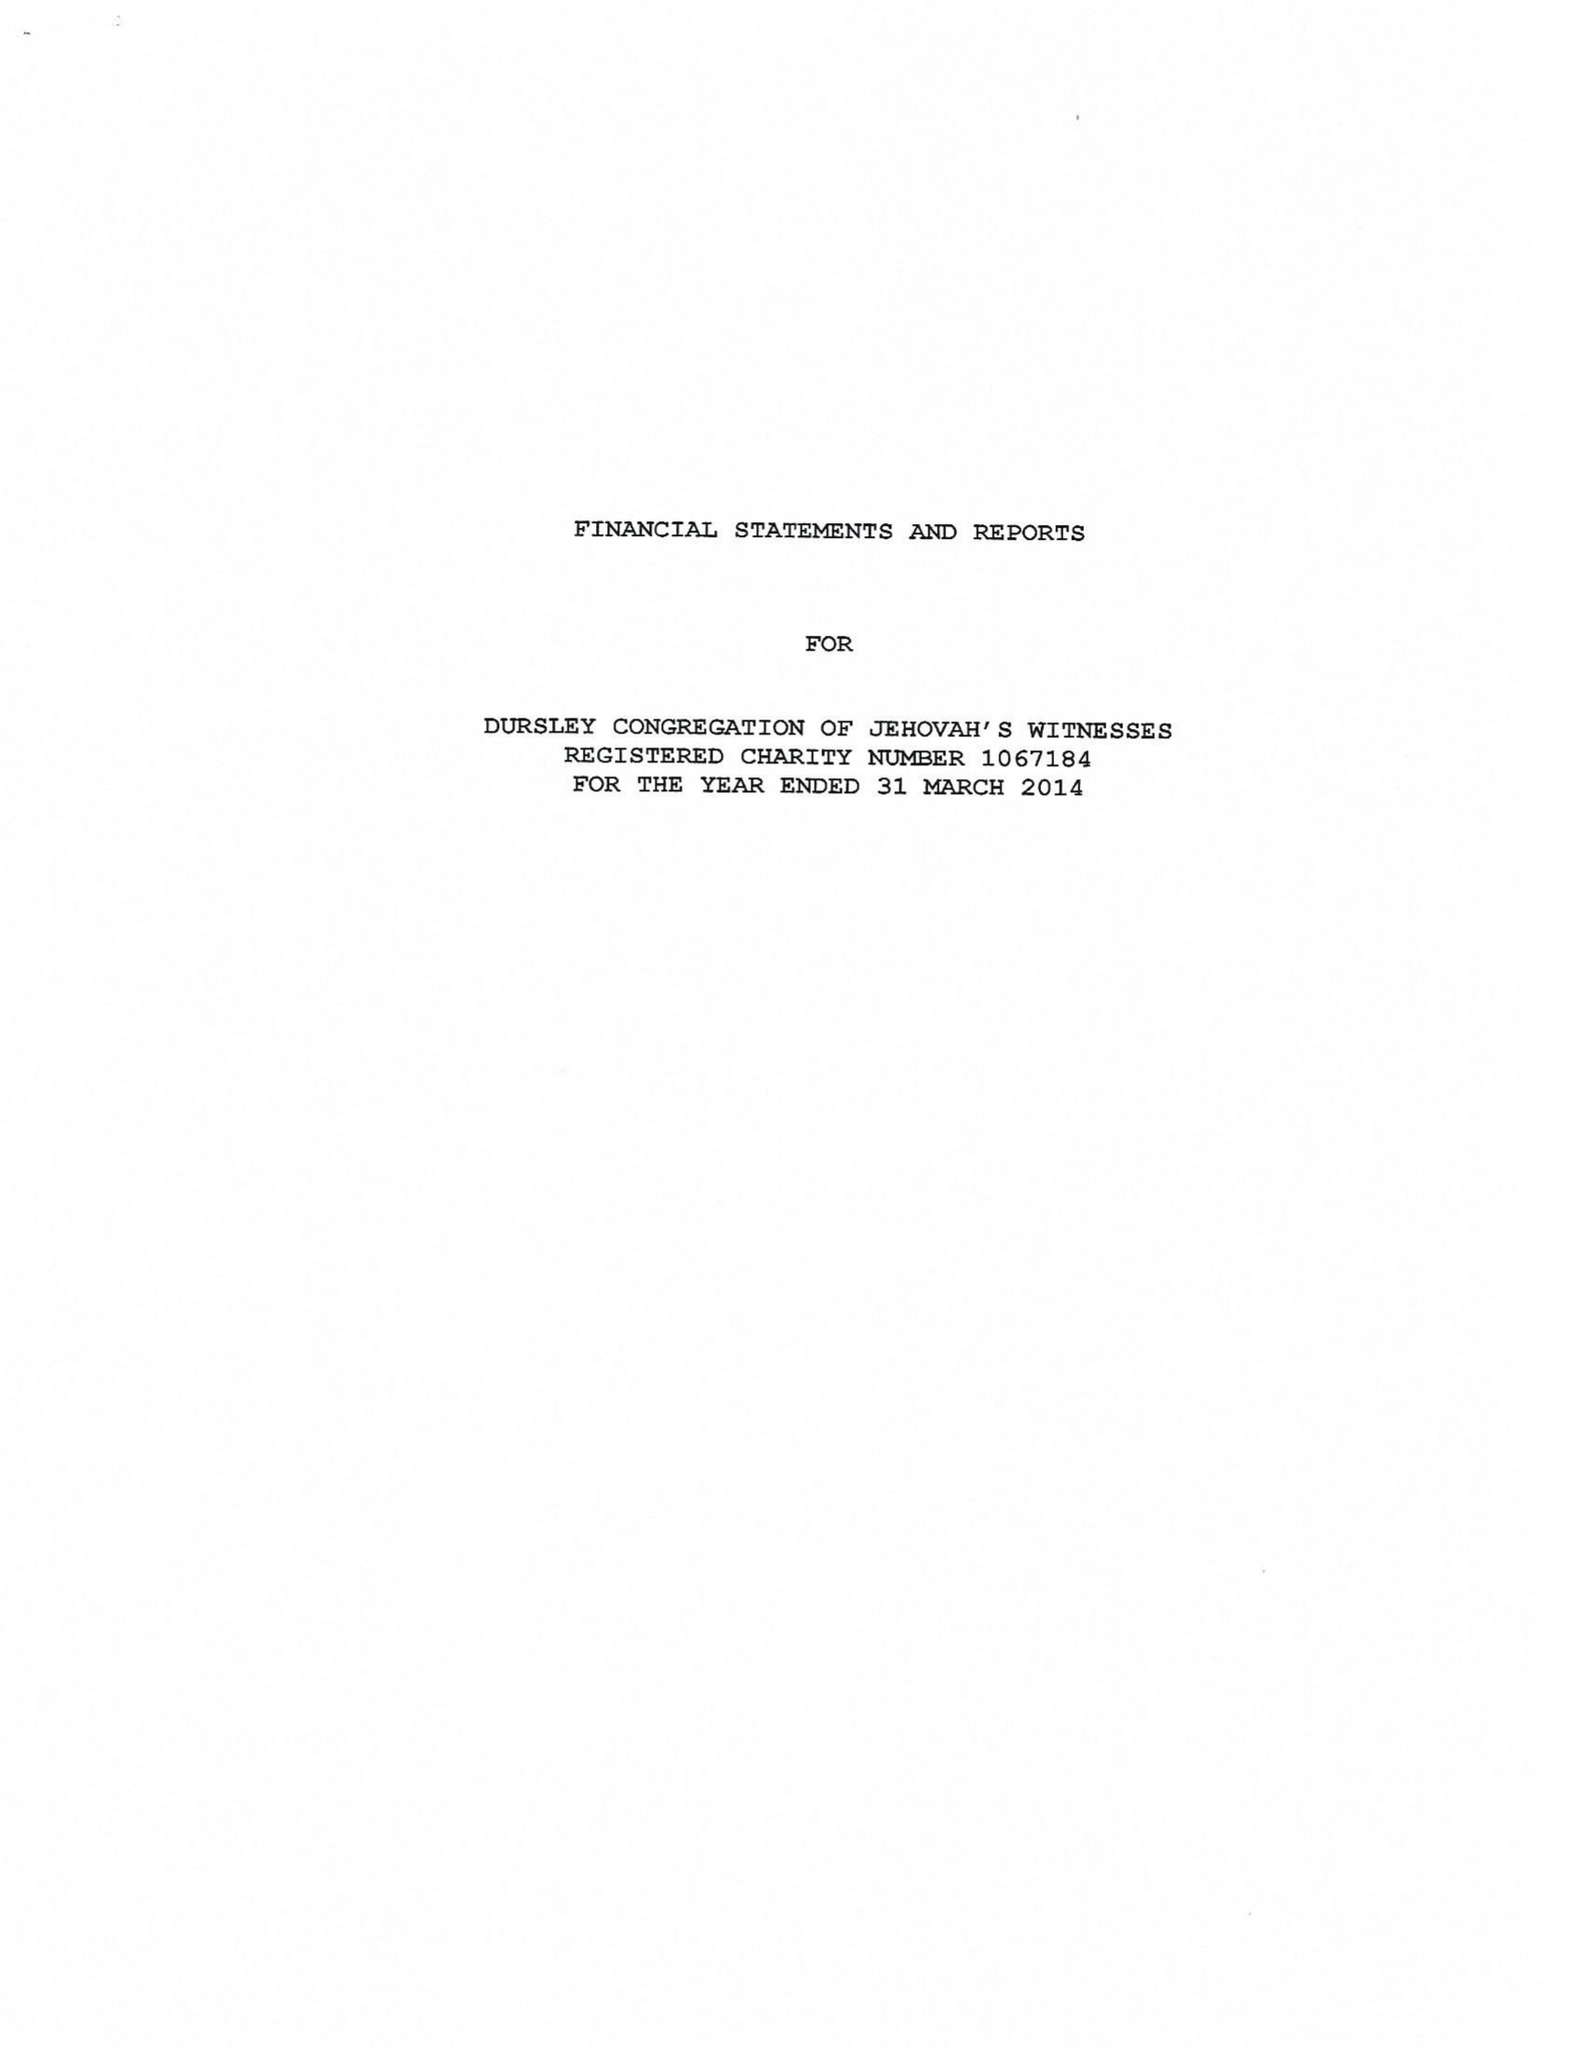What is the value for the address__post_town?
Answer the question using a single word or phrase. DURSLEY 